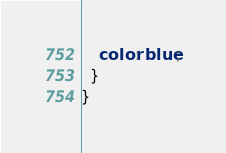Convert code to text. <code><loc_0><loc_0><loc_500><loc_500><_CSS_>    color: blue;
  }
}
</code> 